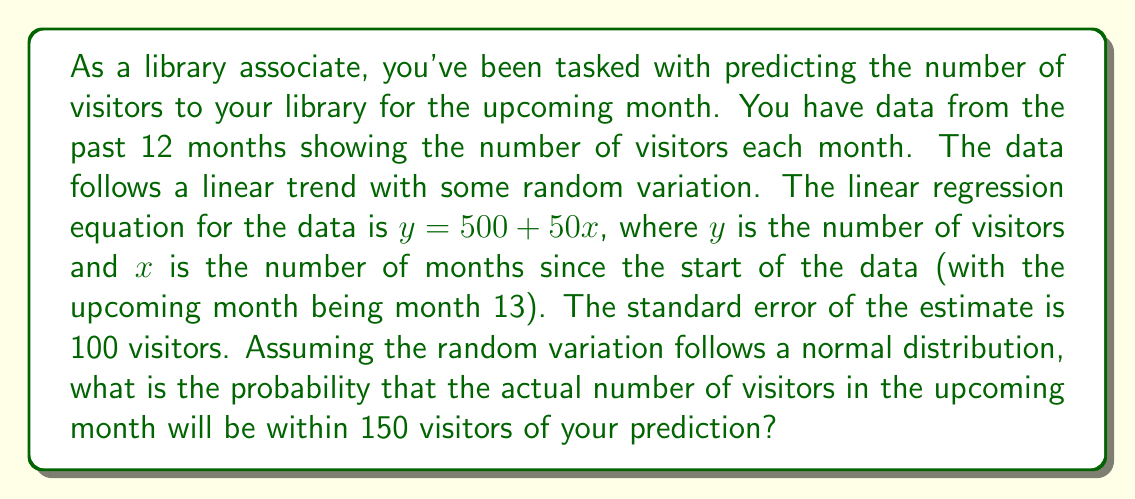Give your solution to this math problem. Let's approach this step-by-step:

1) First, we need to predict the number of visitors for the upcoming month (month 13):
   $y = 500 + 50(13) = 1150$ visitors

2) The question asks about the probability of being within 150 visitors of this prediction. This means we're looking at the range from 1000 to 1300 visitors.

3) We're told that the random variation follows a normal distribution with a standard error of 100 visitors. This means our prediction follows a normal distribution with:
   Mean (μ) = 1150
   Standard deviation (σ) = 100

4) To find the probability, we need to calculate the z-scores for the upper and lower bounds of our range:

   Lower z-score: $z_1 = \frac{1000 - 1150}{100} = -1.5$
   Upper z-score: $z_2 = \frac{1300 - 1150}{100} = 1.5$

5) The probability we're looking for is the area between these two z-scores on a standard normal distribution.

6) Using a standard normal table or calculator, we can find:
   P(z < -1.5) ≈ 0.0668
   P(z < 1.5) ≈ 0.9332

7) The probability we want is the difference between these:
   0.9332 - 0.0668 = 0.8664

Therefore, there is approximately an 86.64% chance that the actual number of visitors will be within 150 of our prediction.
Answer: 0.8664 or 86.64% 